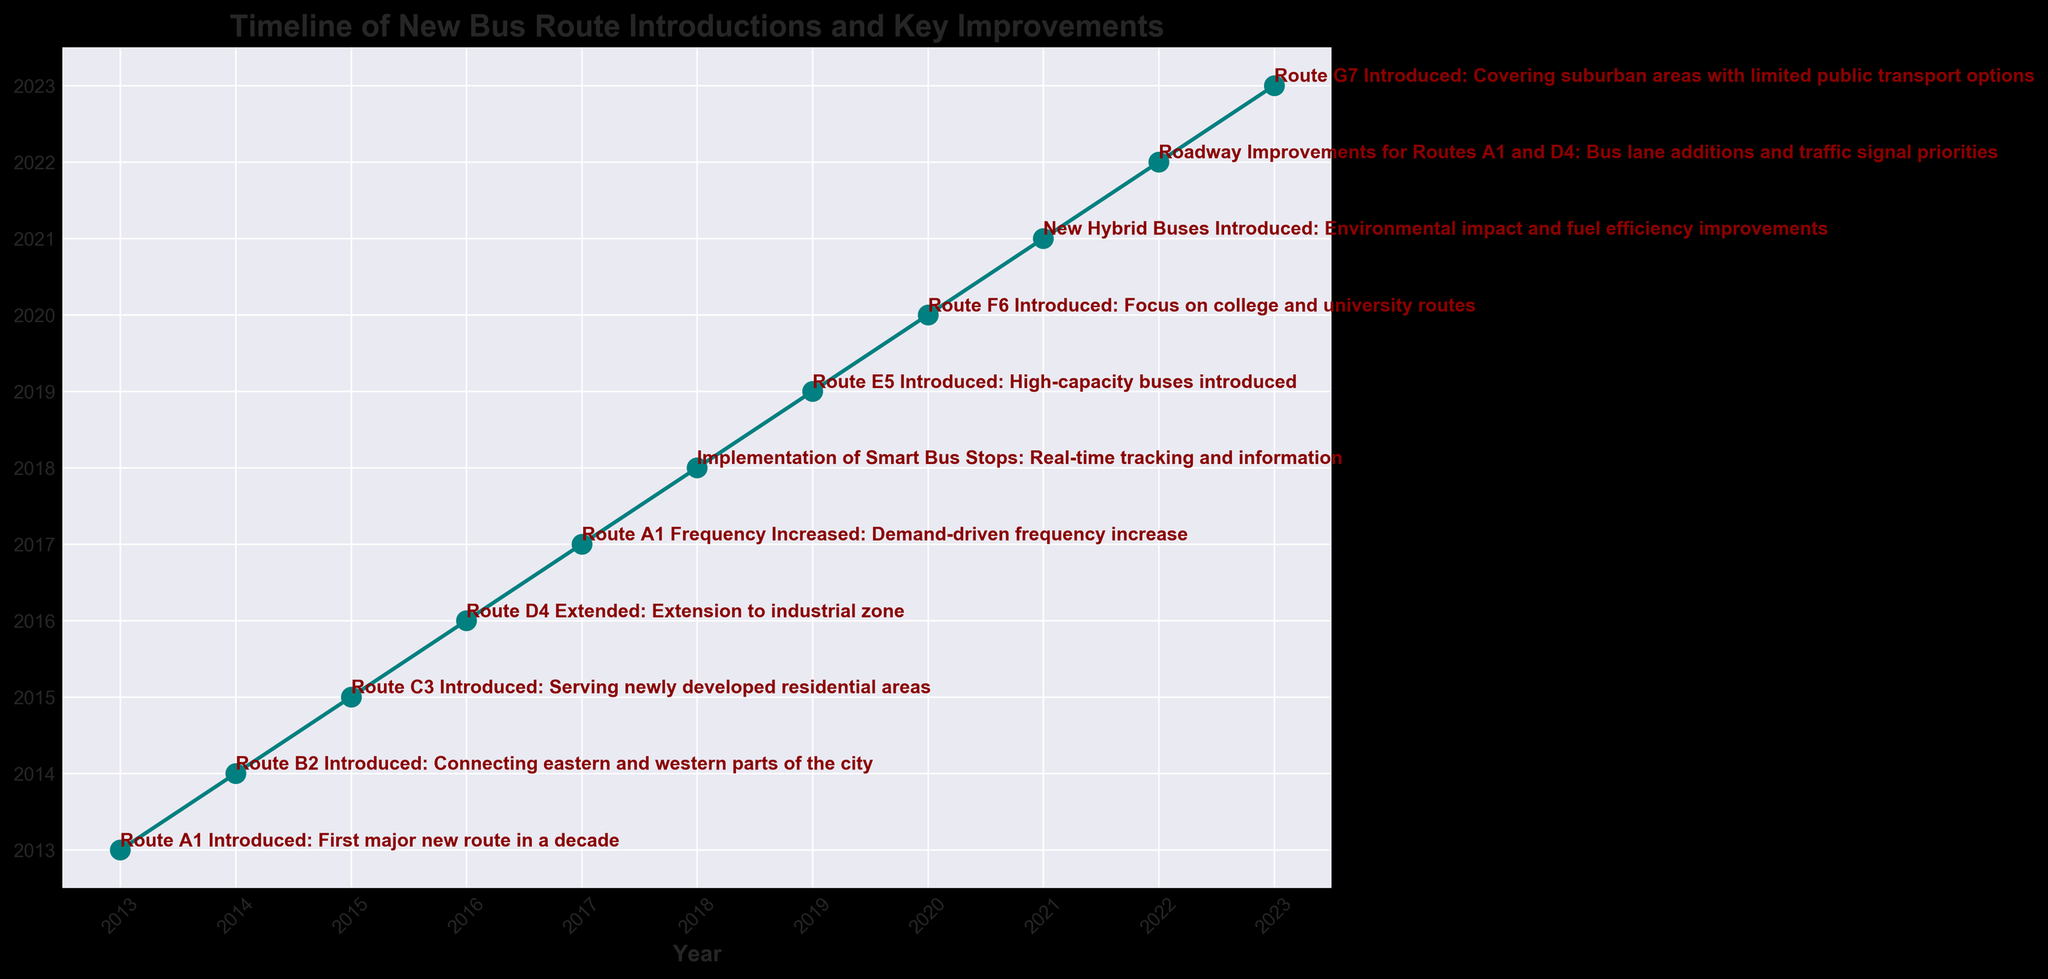What was the first major new bus route introduced in the past decade? The figure shows that the first major new bus route introduced was Route A1 in 2013. This is annotated with "First major new route in a decade."
Answer: Route A1 Which bus route was implemented to connect the eastern and western parts of the city? Referring to the figure, Route B2 was introduced in 2014, and the comment clearly indicates it connects the eastern and western parts of the city.
Answer: Route B2 What environmental improvement was made to the bus services in 2021? The figure shows that new hybrid buses were introduced in 2021, with a comment about environmental impact and fuel efficiency improvements.
Answer: New hybrid buses Calculate the number of new routes introduced between 2013 and 2023. Summing the new routes introduced: Route A1 (2013), Route B2 (2014), Route C3 (2015), Route E5 (2019), Route F6 (2020), and Route G7 (2023). This gives a total of 6 new routes.
Answer: 6 What milestone in 2018 focused on enhancing the commuter experience? The figure shows that the implementation of smart bus stops occurred in 2018, indicating a focus on real-time tracking and information.
Answer: Implementation of smart bus stops Which years experienced route extensions or frequency increases? Referring to the figure, the Route D4 extension happened in 2016, and the frequency increase for Route A1 occurred in 2017.
Answer: 2016 and 2017 How many years after Route A1 was introduced did the first bus route extension occur? Route A1 was introduced in 2013, and Route D4 was extended in 2016. The difference is 2016 - 2013 = 3 years.
Answer: 3 years Compare the routes introduced in 2019 and 2020 based on their target focus. In 2019, Route E5 was introduced with high-capacity buses, whereas in 2020, Route F6 was introduced with a focus on college and university routes.
Answer: High-capacity buses vs college/university route 